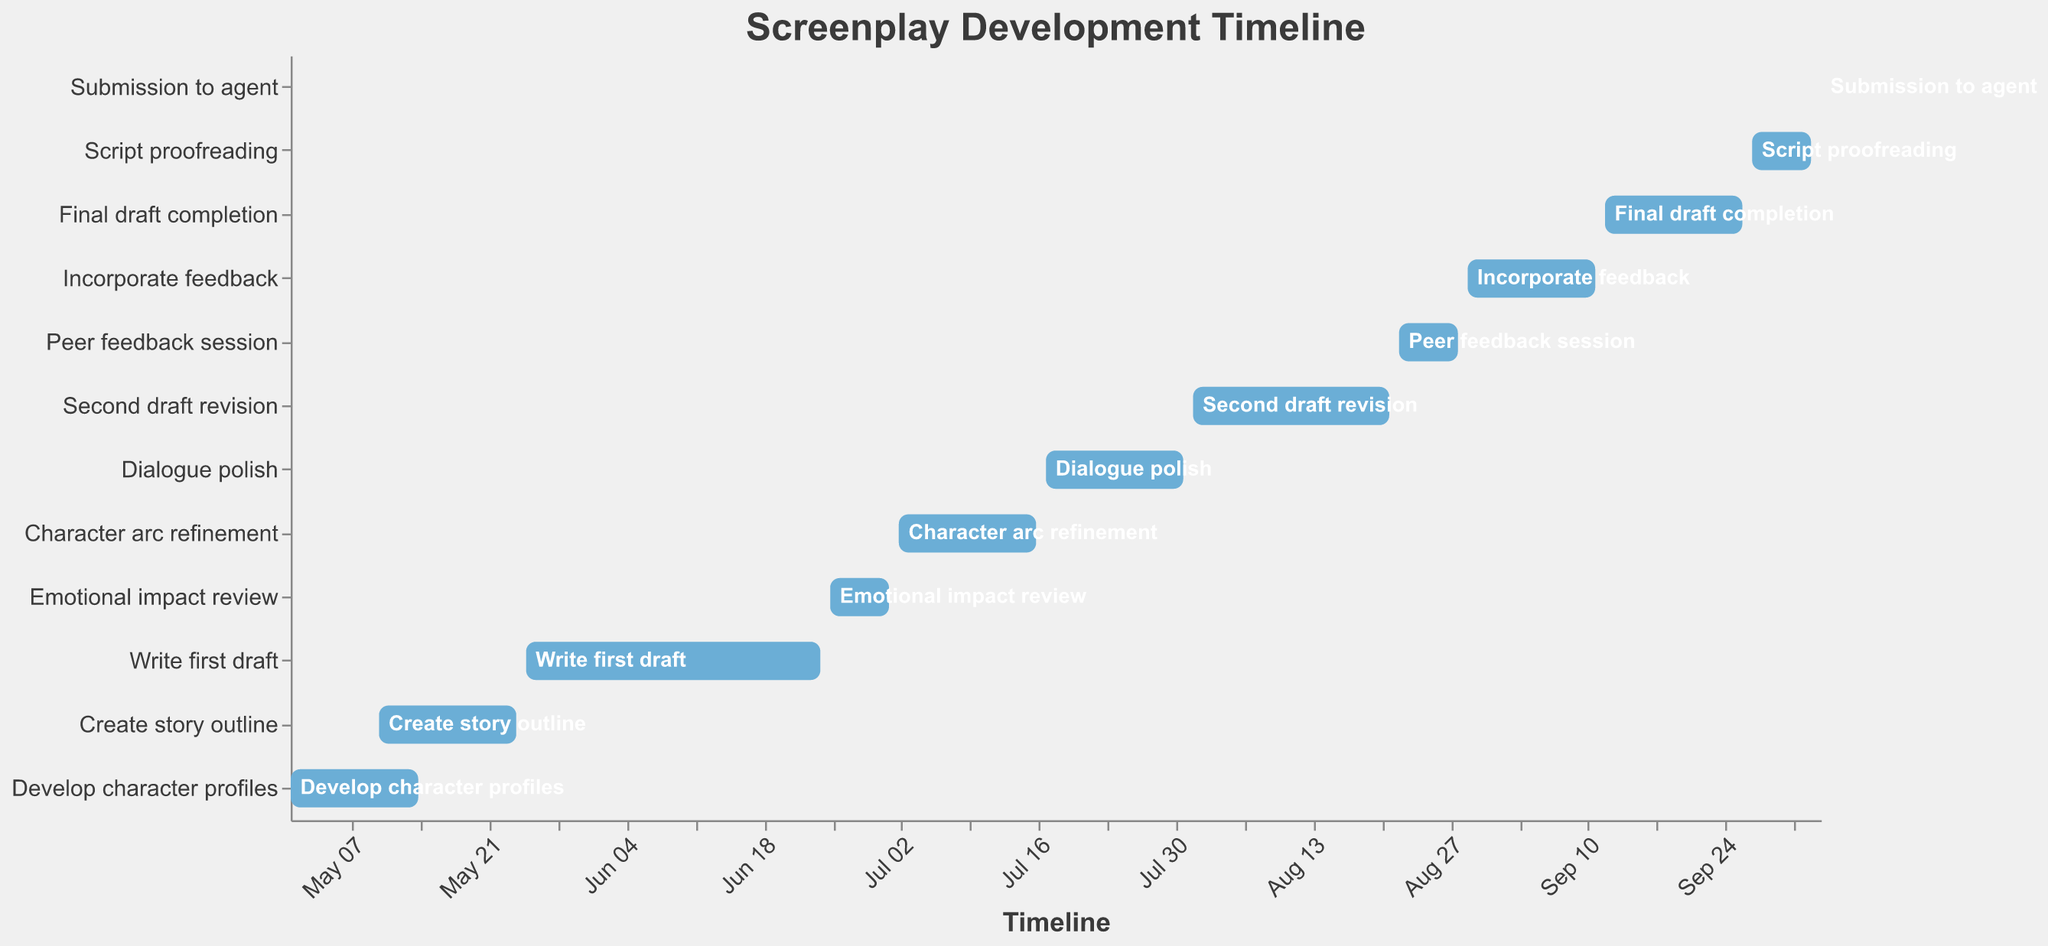what is the total duration of the entire screenplay development process? To find the total duration, calculate the span from the start date of the first task to the end date of the last task. The first task starts on 2023-05-01 and the last task ends on 2023-10-04. The overall duration is from May 1st to October 4th, which is 157 days.
Answer: 157 days Which task has the shortest duration? Look for the task with the smallest duration. "Submission to agent" is the shortest, with only 1 day.
Answer: Submission to agent How many days does it take to write the second draft? Check the duration of the "Second draft revision". It shows a duration of 21 days.
Answer: 21 days What tasks overlap with "Create story outline"? Look for tasks with start dates before or on 2023-05-10 and end dates after or on 2023-05-24. "Develop character profiles" overlaps with these dates.
Answer: Develop character profiles How long does it take to complete "Dialogue polish" after "Character arc refinement"? Calculate the time difference between the end of "Character arc refinement" (2023-07-16) to the start of "Dialogue polish" (2023-07-17). They start consecutively without any gap.
Answer: 0 days Which task immediately follows the "Emotional impact review"? Identify the task that starts right after the "Emotional impact review" ends on 2023-07-01. "Character arc refinement" starts on 2023-07-02.
Answer: Character arc refinement What is the total duration of all tasks contributing to drafts (first, second, final)? Sum the durations of "Write first draft" (31 days), "Second draft revision" (21 days) and "Final draft completion" (15 days). The total is 67 days.
Answer: 67 days If "Incorporate feedback" is delayed by one week, how does it affect the final submission date? Calculate the new end date of "Incorporate feedback" (2023-09-18). Then, adjust the subsequent tasks accordingly. The final submission to the agent would be delayed to October 11th.
Answer: October 11th How many tasks are involved in revising drafts? Count the tasks: "Second draft revision" and "Final draft completion". There are 2 tasks.
Answer: 2 tasks 